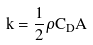Convert formula to latex. <formula><loc_0><loc_0><loc_500><loc_500>k = \frac { 1 } { 2 } \rho C _ { D } A</formula> 